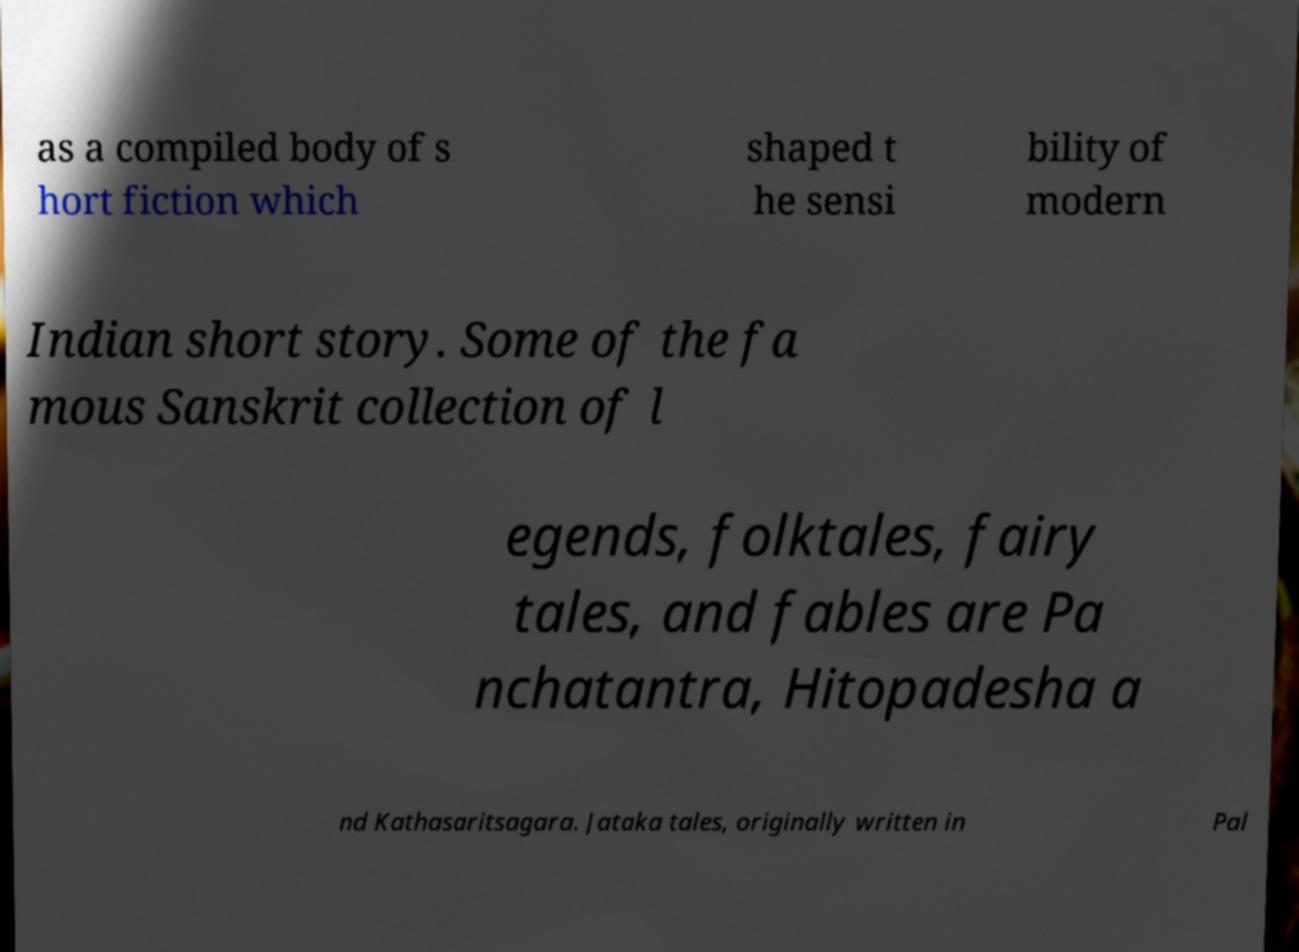Can you read and provide the text displayed in the image?This photo seems to have some interesting text. Can you extract and type it out for me? as a compiled body of s hort fiction which shaped t he sensi bility of modern Indian short story. Some of the fa mous Sanskrit collection of l egends, folktales, fairy tales, and fables are Pa nchatantra, Hitopadesha a nd Kathasaritsagara. Jataka tales, originally written in Pal 